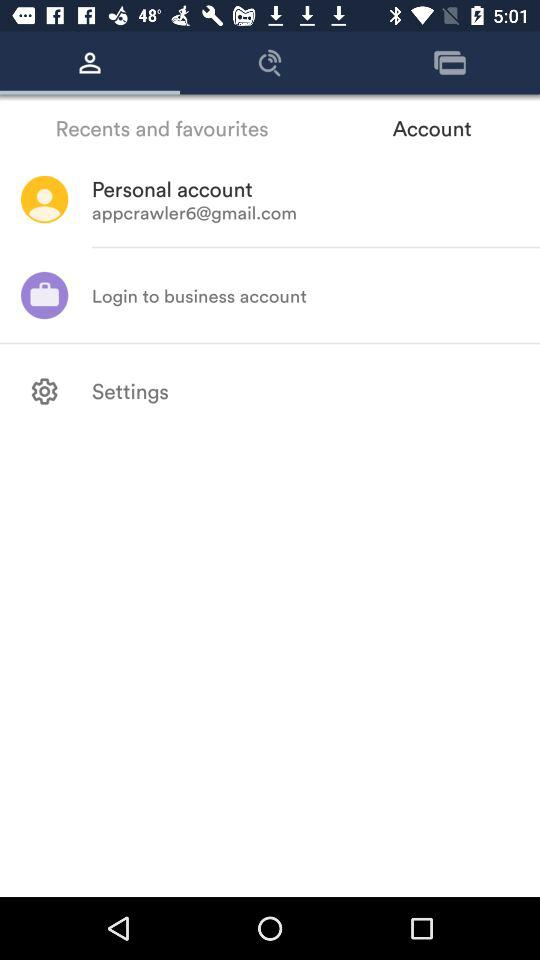What is the email address? The email address is appcrawler6@gmail.com. 